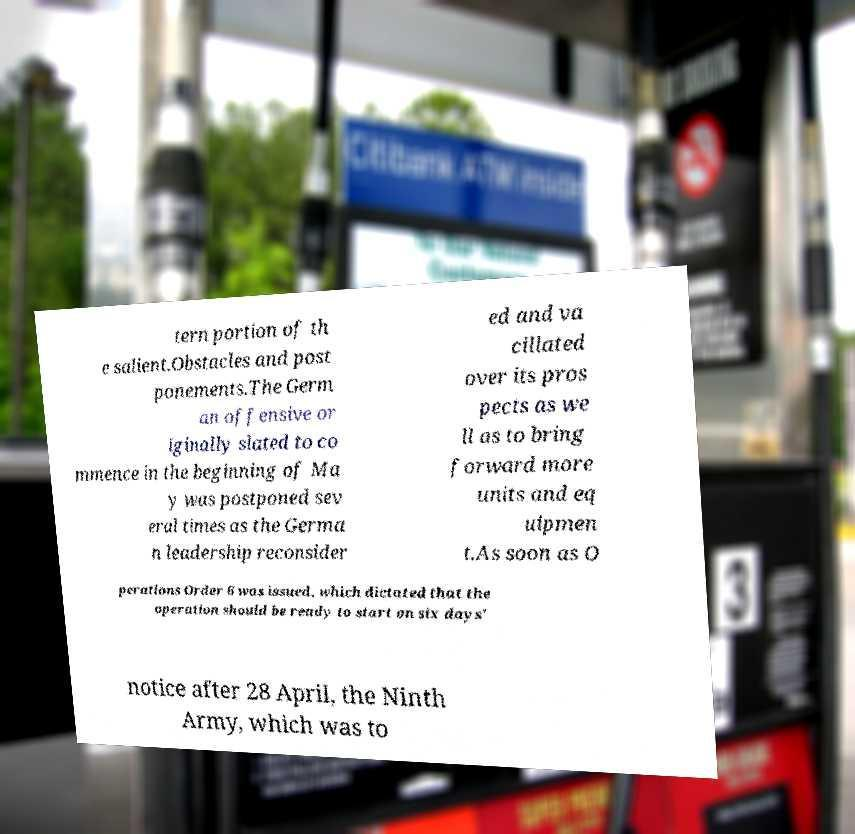Could you extract and type out the text from this image? tern portion of th e salient.Obstacles and post ponements.The Germ an offensive or iginally slated to co mmence in the beginning of Ma y was postponed sev eral times as the Germa n leadership reconsider ed and va cillated over its pros pects as we ll as to bring forward more units and eq uipmen t.As soon as O perations Order 6 was issued, which dictated that the operation should be ready to start on six days' notice after 28 April, the Ninth Army, which was to 